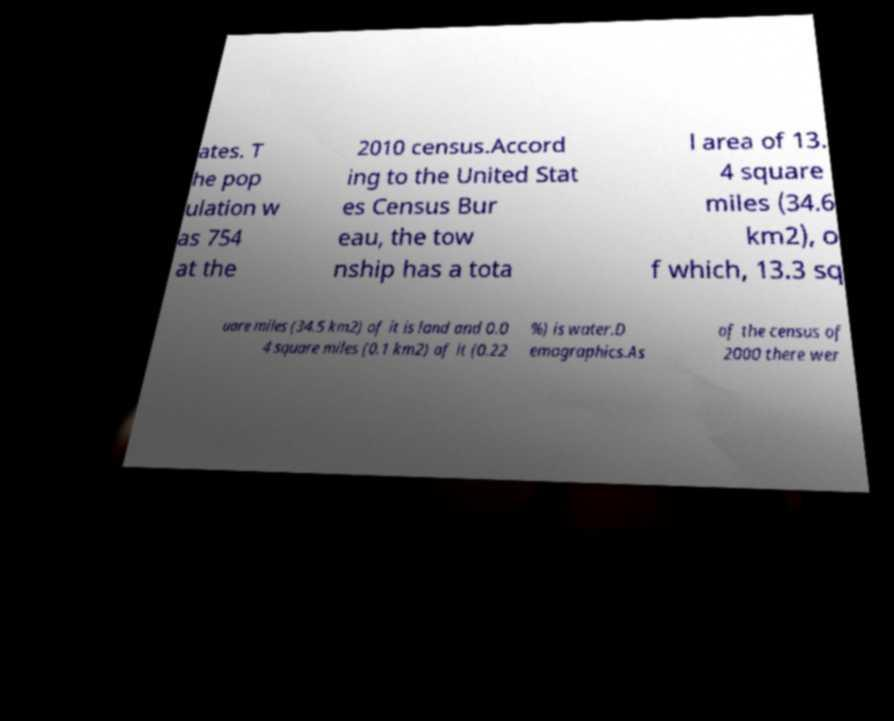Please read and relay the text visible in this image. What does it say? ates. T he pop ulation w as 754 at the 2010 census.Accord ing to the United Stat es Census Bur eau, the tow nship has a tota l area of 13. 4 square miles (34.6 km2), o f which, 13.3 sq uare miles (34.5 km2) of it is land and 0.0 4 square miles (0.1 km2) of it (0.22 %) is water.D emographics.As of the census of 2000 there wer 